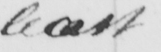Can you tell me what this handwritten text says? least 